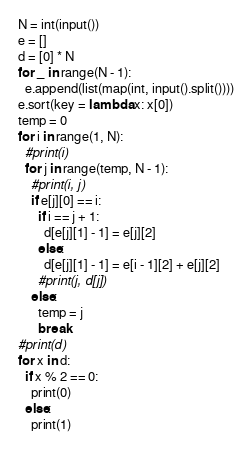Convert code to text. <code><loc_0><loc_0><loc_500><loc_500><_Python_>N = int(input())
e = []
d = [0] * N
for _ in range(N - 1):
  e.append(list(map(int, input().split())))
e.sort(key = lambda x: x[0])
temp = 0
for i in range(1, N):
  #print(i)
  for j in range(temp, N - 1):
    #print(i, j)
    if e[j][0] == i:
      if i == j + 1:
        d[e[j][1] - 1] = e[j][2]
      else:
        d[e[j][1] - 1] = e[i - 1][2] + e[j][2]
      #print(j, d[j])
    else:
      temp = j
      break
#print(d)
for x in d:
  if x % 2 == 0:
    print(0)
  else:
    print(1)</code> 